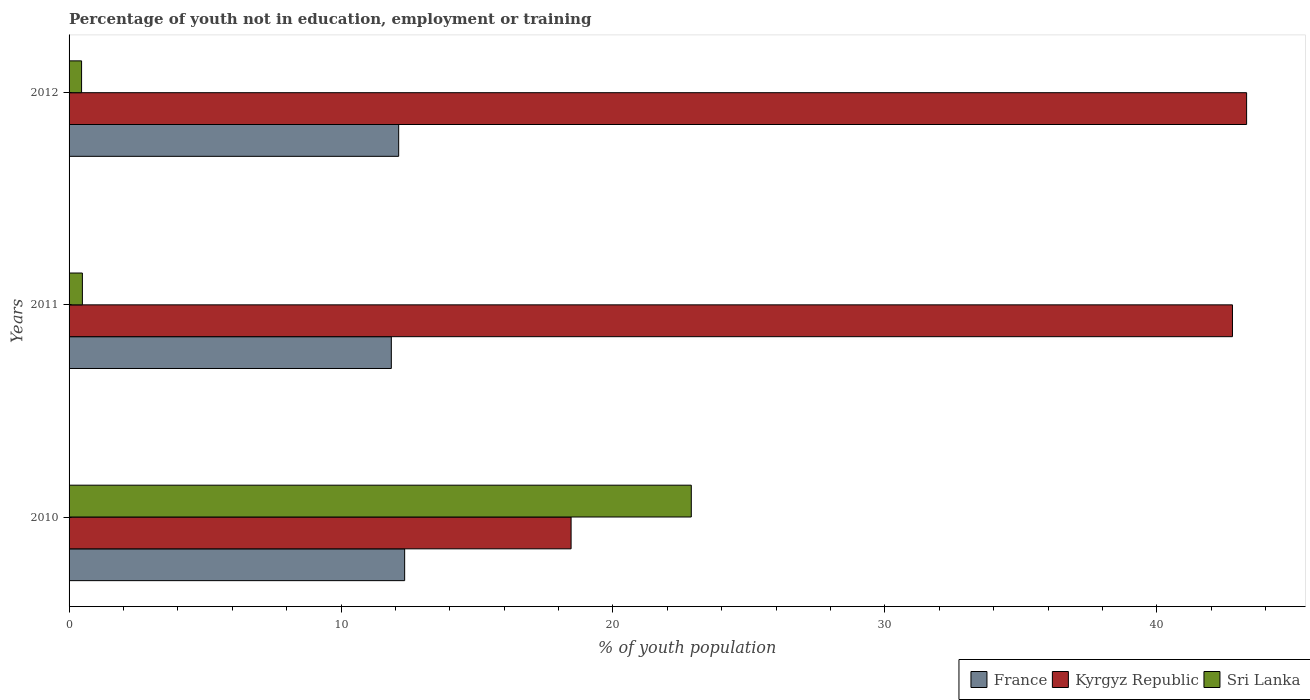How many different coloured bars are there?
Provide a short and direct response. 3. How many groups of bars are there?
Your response must be concise. 3. Are the number of bars on each tick of the Y-axis equal?
Your answer should be very brief. Yes. How many bars are there on the 2nd tick from the top?
Provide a succinct answer. 3. In how many cases, is the number of bars for a given year not equal to the number of legend labels?
Offer a terse response. 0. What is the percentage of unemployed youth population in in Kyrgyz Republic in 2011?
Keep it short and to the point. 42.78. Across all years, what is the maximum percentage of unemployed youth population in in Sri Lanka?
Provide a short and direct response. 22.88. Across all years, what is the minimum percentage of unemployed youth population in in Sri Lanka?
Offer a terse response. 0.46. In which year was the percentage of unemployed youth population in in France maximum?
Provide a short and direct response. 2010. In which year was the percentage of unemployed youth population in in Sri Lanka minimum?
Offer a very short reply. 2012. What is the total percentage of unemployed youth population in in Sri Lanka in the graph?
Offer a terse response. 23.83. What is the difference between the percentage of unemployed youth population in in France in 2010 and that in 2012?
Keep it short and to the point. 0.22. What is the difference between the percentage of unemployed youth population in in France in 2010 and the percentage of unemployed youth population in in Kyrgyz Republic in 2011?
Offer a very short reply. -30.44. What is the average percentage of unemployed youth population in in France per year?
Provide a short and direct response. 12.1. In the year 2010, what is the difference between the percentage of unemployed youth population in in Kyrgyz Republic and percentage of unemployed youth population in in Sri Lanka?
Ensure brevity in your answer.  -4.42. What is the ratio of the percentage of unemployed youth population in in Kyrgyz Republic in 2010 to that in 2011?
Offer a terse response. 0.43. Is the percentage of unemployed youth population in in Kyrgyz Republic in 2010 less than that in 2011?
Keep it short and to the point. Yes. What is the difference between the highest and the second highest percentage of unemployed youth population in in France?
Provide a succinct answer. 0.22. What is the difference between the highest and the lowest percentage of unemployed youth population in in Sri Lanka?
Your response must be concise. 22.42. What does the 1st bar from the top in 2011 represents?
Keep it short and to the point. Sri Lanka. What does the 2nd bar from the bottom in 2010 represents?
Offer a terse response. Kyrgyz Republic. Is it the case that in every year, the sum of the percentage of unemployed youth population in in Kyrgyz Republic and percentage of unemployed youth population in in France is greater than the percentage of unemployed youth population in in Sri Lanka?
Provide a short and direct response. Yes. How many bars are there?
Offer a very short reply. 9. Are all the bars in the graph horizontal?
Provide a succinct answer. Yes. How many years are there in the graph?
Ensure brevity in your answer.  3. What is the difference between two consecutive major ticks on the X-axis?
Give a very brief answer. 10. Does the graph contain any zero values?
Your answer should be compact. No. Where does the legend appear in the graph?
Offer a very short reply. Bottom right. What is the title of the graph?
Provide a succinct answer. Percentage of youth not in education, employment or training. Does "Tonga" appear as one of the legend labels in the graph?
Keep it short and to the point. No. What is the label or title of the X-axis?
Your answer should be very brief. % of youth population. What is the label or title of the Y-axis?
Give a very brief answer. Years. What is the % of youth population of France in 2010?
Provide a succinct answer. 12.34. What is the % of youth population of Kyrgyz Republic in 2010?
Ensure brevity in your answer.  18.46. What is the % of youth population in Sri Lanka in 2010?
Your answer should be very brief. 22.88. What is the % of youth population of France in 2011?
Your answer should be very brief. 11.85. What is the % of youth population of Kyrgyz Republic in 2011?
Your answer should be very brief. 42.78. What is the % of youth population in Sri Lanka in 2011?
Provide a short and direct response. 0.49. What is the % of youth population in France in 2012?
Keep it short and to the point. 12.12. What is the % of youth population of Kyrgyz Republic in 2012?
Your response must be concise. 43.3. What is the % of youth population of Sri Lanka in 2012?
Offer a very short reply. 0.46. Across all years, what is the maximum % of youth population of France?
Offer a very short reply. 12.34. Across all years, what is the maximum % of youth population in Kyrgyz Republic?
Offer a terse response. 43.3. Across all years, what is the maximum % of youth population in Sri Lanka?
Your answer should be compact. 22.88. Across all years, what is the minimum % of youth population of France?
Offer a very short reply. 11.85. Across all years, what is the minimum % of youth population of Kyrgyz Republic?
Your response must be concise. 18.46. Across all years, what is the minimum % of youth population of Sri Lanka?
Your answer should be very brief. 0.46. What is the total % of youth population in France in the graph?
Your response must be concise. 36.31. What is the total % of youth population in Kyrgyz Republic in the graph?
Keep it short and to the point. 104.54. What is the total % of youth population of Sri Lanka in the graph?
Keep it short and to the point. 23.83. What is the difference between the % of youth population of France in 2010 and that in 2011?
Keep it short and to the point. 0.49. What is the difference between the % of youth population of Kyrgyz Republic in 2010 and that in 2011?
Your answer should be compact. -24.32. What is the difference between the % of youth population of Sri Lanka in 2010 and that in 2011?
Give a very brief answer. 22.39. What is the difference between the % of youth population of France in 2010 and that in 2012?
Provide a succinct answer. 0.22. What is the difference between the % of youth population of Kyrgyz Republic in 2010 and that in 2012?
Ensure brevity in your answer.  -24.84. What is the difference between the % of youth population of Sri Lanka in 2010 and that in 2012?
Your answer should be very brief. 22.42. What is the difference between the % of youth population in France in 2011 and that in 2012?
Your answer should be compact. -0.27. What is the difference between the % of youth population of Kyrgyz Republic in 2011 and that in 2012?
Provide a succinct answer. -0.52. What is the difference between the % of youth population of Sri Lanka in 2011 and that in 2012?
Your answer should be compact. 0.03. What is the difference between the % of youth population of France in 2010 and the % of youth population of Kyrgyz Republic in 2011?
Offer a very short reply. -30.44. What is the difference between the % of youth population of France in 2010 and the % of youth population of Sri Lanka in 2011?
Provide a succinct answer. 11.85. What is the difference between the % of youth population in Kyrgyz Republic in 2010 and the % of youth population in Sri Lanka in 2011?
Your answer should be compact. 17.97. What is the difference between the % of youth population of France in 2010 and the % of youth population of Kyrgyz Republic in 2012?
Your response must be concise. -30.96. What is the difference between the % of youth population of France in 2010 and the % of youth population of Sri Lanka in 2012?
Your response must be concise. 11.88. What is the difference between the % of youth population in Kyrgyz Republic in 2010 and the % of youth population in Sri Lanka in 2012?
Provide a short and direct response. 18. What is the difference between the % of youth population in France in 2011 and the % of youth population in Kyrgyz Republic in 2012?
Offer a terse response. -31.45. What is the difference between the % of youth population of France in 2011 and the % of youth population of Sri Lanka in 2012?
Ensure brevity in your answer.  11.39. What is the difference between the % of youth population in Kyrgyz Republic in 2011 and the % of youth population in Sri Lanka in 2012?
Keep it short and to the point. 42.32. What is the average % of youth population in France per year?
Keep it short and to the point. 12.1. What is the average % of youth population of Kyrgyz Republic per year?
Provide a succinct answer. 34.85. What is the average % of youth population in Sri Lanka per year?
Your response must be concise. 7.94. In the year 2010, what is the difference between the % of youth population of France and % of youth population of Kyrgyz Republic?
Your response must be concise. -6.12. In the year 2010, what is the difference between the % of youth population in France and % of youth population in Sri Lanka?
Your answer should be compact. -10.54. In the year 2010, what is the difference between the % of youth population of Kyrgyz Republic and % of youth population of Sri Lanka?
Provide a succinct answer. -4.42. In the year 2011, what is the difference between the % of youth population in France and % of youth population in Kyrgyz Republic?
Your answer should be very brief. -30.93. In the year 2011, what is the difference between the % of youth population of France and % of youth population of Sri Lanka?
Your answer should be compact. 11.36. In the year 2011, what is the difference between the % of youth population of Kyrgyz Republic and % of youth population of Sri Lanka?
Your response must be concise. 42.29. In the year 2012, what is the difference between the % of youth population of France and % of youth population of Kyrgyz Republic?
Provide a succinct answer. -31.18. In the year 2012, what is the difference between the % of youth population of France and % of youth population of Sri Lanka?
Your answer should be very brief. 11.66. In the year 2012, what is the difference between the % of youth population in Kyrgyz Republic and % of youth population in Sri Lanka?
Offer a very short reply. 42.84. What is the ratio of the % of youth population of France in 2010 to that in 2011?
Provide a short and direct response. 1.04. What is the ratio of the % of youth population of Kyrgyz Republic in 2010 to that in 2011?
Your answer should be very brief. 0.43. What is the ratio of the % of youth population of Sri Lanka in 2010 to that in 2011?
Keep it short and to the point. 46.69. What is the ratio of the % of youth population in France in 2010 to that in 2012?
Make the answer very short. 1.02. What is the ratio of the % of youth population of Kyrgyz Republic in 2010 to that in 2012?
Your answer should be very brief. 0.43. What is the ratio of the % of youth population in Sri Lanka in 2010 to that in 2012?
Your response must be concise. 49.74. What is the ratio of the % of youth population of France in 2011 to that in 2012?
Provide a short and direct response. 0.98. What is the ratio of the % of youth population of Sri Lanka in 2011 to that in 2012?
Your answer should be very brief. 1.07. What is the difference between the highest and the second highest % of youth population in France?
Ensure brevity in your answer.  0.22. What is the difference between the highest and the second highest % of youth population of Kyrgyz Republic?
Offer a terse response. 0.52. What is the difference between the highest and the second highest % of youth population in Sri Lanka?
Give a very brief answer. 22.39. What is the difference between the highest and the lowest % of youth population in France?
Make the answer very short. 0.49. What is the difference between the highest and the lowest % of youth population in Kyrgyz Republic?
Offer a very short reply. 24.84. What is the difference between the highest and the lowest % of youth population of Sri Lanka?
Offer a terse response. 22.42. 